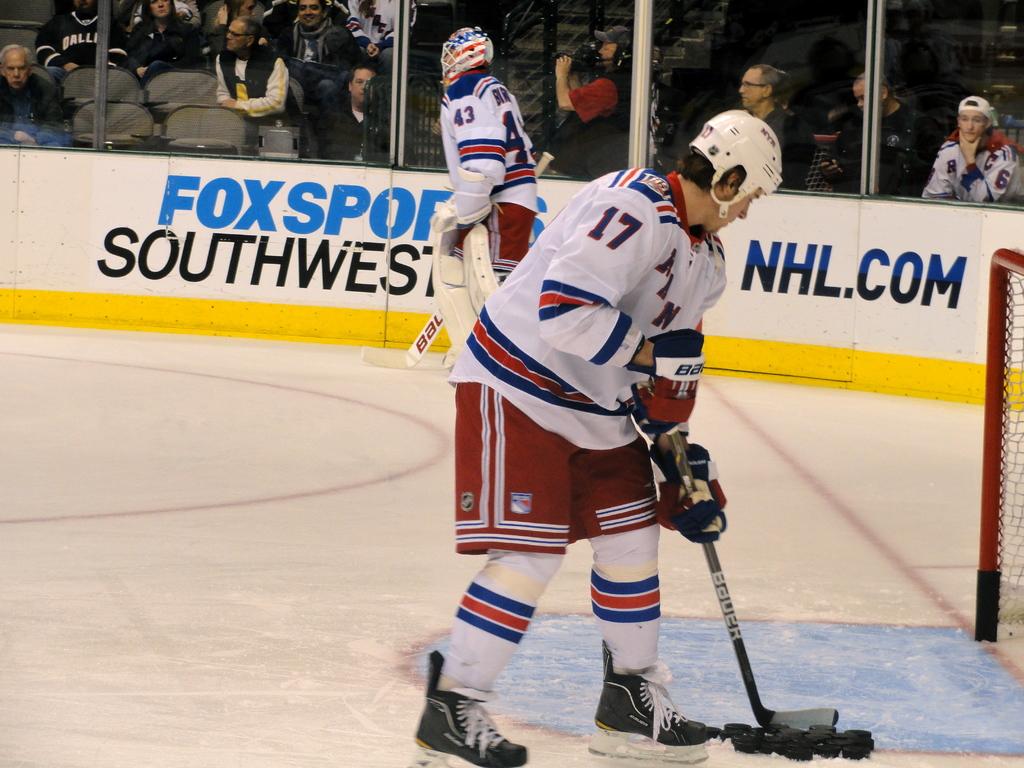Which website is advertised on the right?
Give a very brief answer. Nhl.com. 